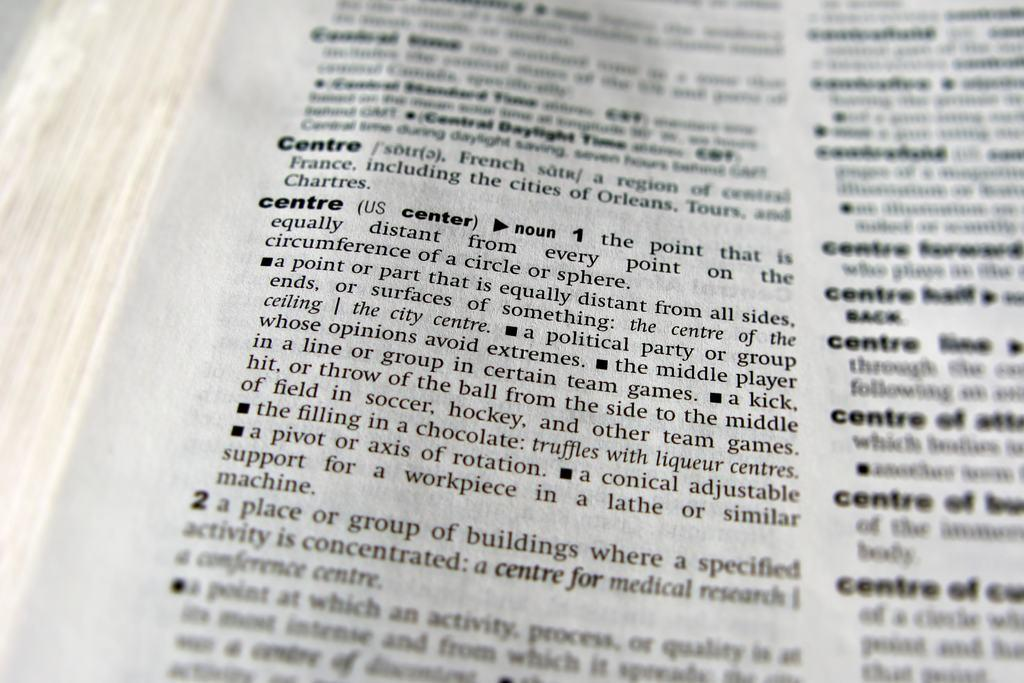<image>
Provide a brief description of the given image. the word centre that has many words near it 